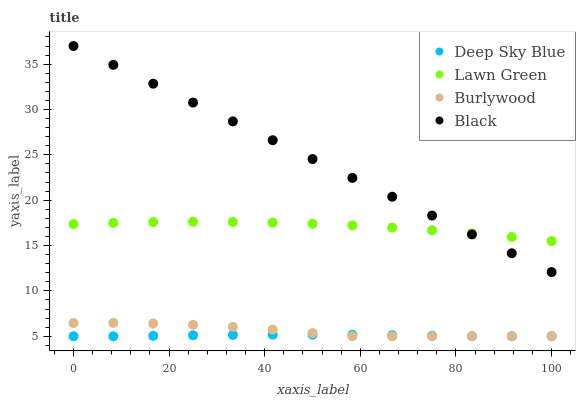Does Deep Sky Blue have the minimum area under the curve?
Answer yes or no. Yes. Does Black have the maximum area under the curve?
Answer yes or no. Yes. Does Lawn Green have the minimum area under the curve?
Answer yes or no. No. Does Lawn Green have the maximum area under the curve?
Answer yes or no. No. Is Black the smoothest?
Answer yes or no. Yes. Is Burlywood the roughest?
Answer yes or no. Yes. Is Lawn Green the smoothest?
Answer yes or no. No. Is Lawn Green the roughest?
Answer yes or no. No. Does Burlywood have the lowest value?
Answer yes or no. Yes. Does Black have the lowest value?
Answer yes or no. No. Does Black have the highest value?
Answer yes or no. Yes. Does Lawn Green have the highest value?
Answer yes or no. No. Is Burlywood less than Black?
Answer yes or no. Yes. Is Lawn Green greater than Deep Sky Blue?
Answer yes or no. Yes. Does Deep Sky Blue intersect Burlywood?
Answer yes or no. Yes. Is Deep Sky Blue less than Burlywood?
Answer yes or no. No. Is Deep Sky Blue greater than Burlywood?
Answer yes or no. No. Does Burlywood intersect Black?
Answer yes or no. No. 